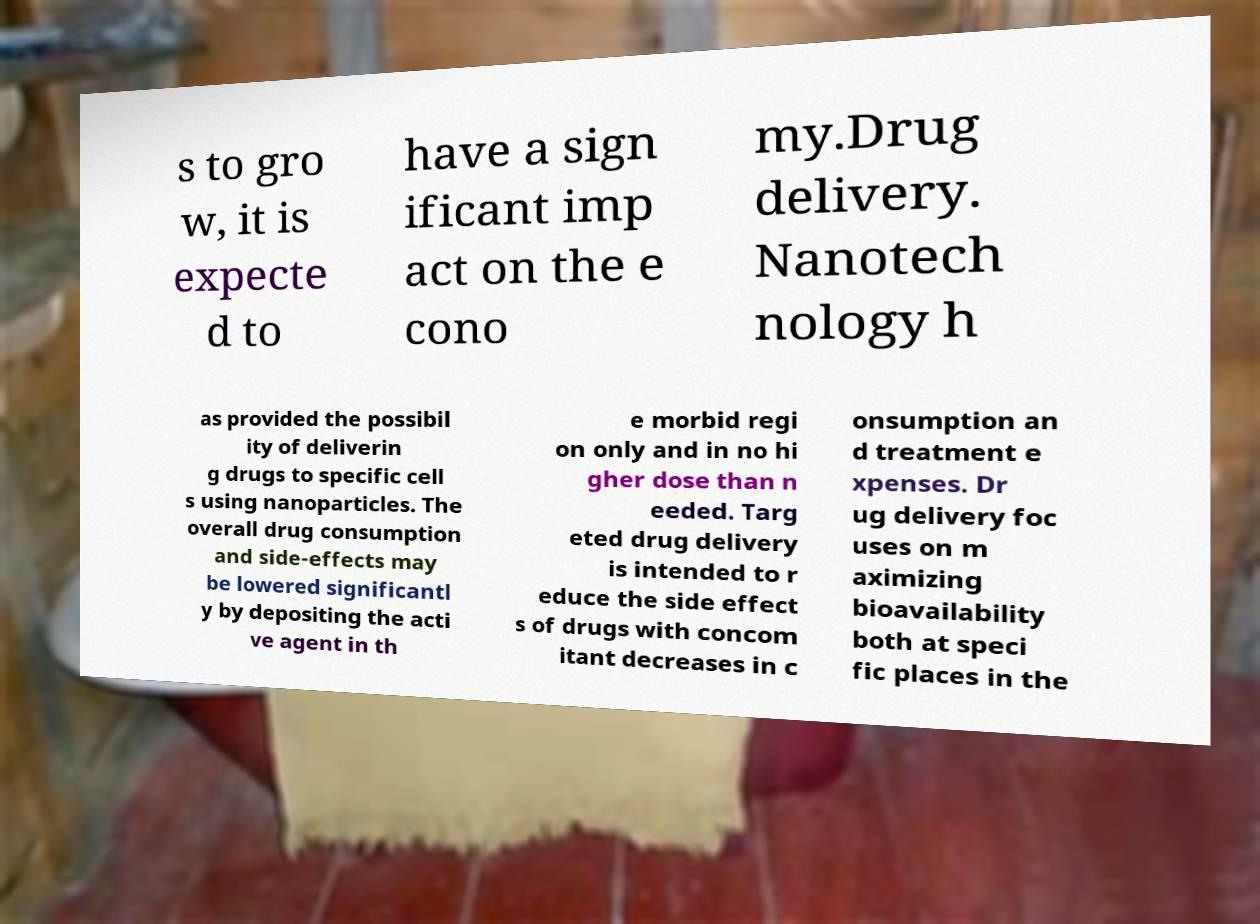Could you assist in decoding the text presented in this image and type it out clearly? s to gro w, it is expecte d to have a sign ificant imp act on the e cono my.Drug delivery. Nanotech nology h as provided the possibil ity of deliverin g drugs to specific cell s using nanoparticles. The overall drug consumption and side-effects may be lowered significantl y by depositing the acti ve agent in th e morbid regi on only and in no hi gher dose than n eeded. Targ eted drug delivery is intended to r educe the side effect s of drugs with concom itant decreases in c onsumption an d treatment e xpenses. Dr ug delivery foc uses on m aximizing bioavailability both at speci fic places in the 